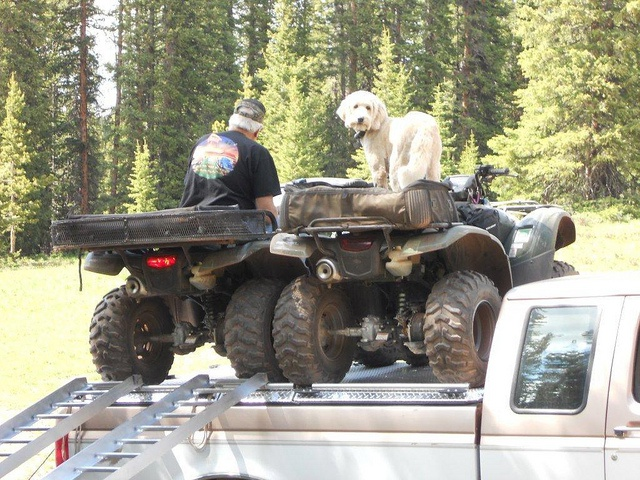Describe the objects in this image and their specific colors. I can see truck in tan, gray, black, and darkgray tones, truck in tan, white, darkgray, and gray tones, people in tan, black, gray, lightgray, and darkgray tones, suitcase in tan, gray, and darkgray tones, and dog in tan, ivory, and darkgray tones in this image. 